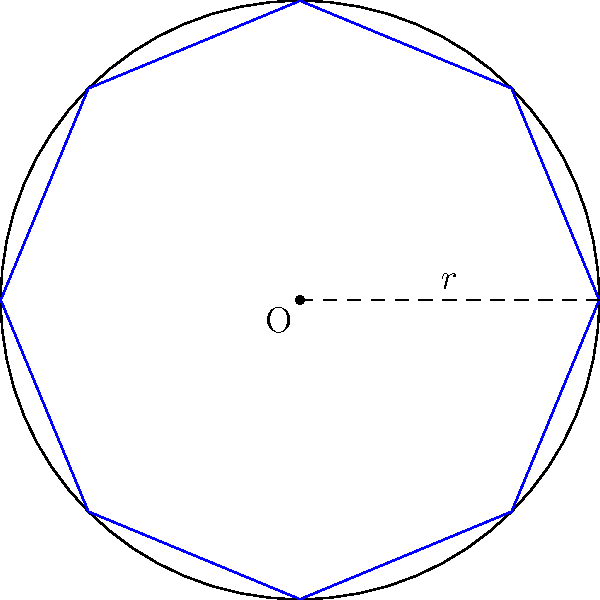A circle with radius $r$ has a regular octagon inscribed within it, as shown in the figure. If the radius of the circle is 10 cm, what is the perimeter of the inscribed octagon? Express your answer in terms of $\pi$ cm, rounded to two decimal places. Let's approach this step-by-step:

1) In a regular octagon, the central angle between any two adjacent vertices is $\frac{360°}{8} = 45°$.

2) The octagon can be divided into 8 congruent right triangles. Let's focus on one of these triangles.

3) In this right triangle:
   - The hypotenuse is the radius $r = 10$ cm.
   - The angle at the center is half of $45°$, which is $22.5°$.

4) The side of the octagon forms the base of this right triangle. Let's call its length $s$.

5) We can find $s$ using the cosine function:

   $\cos 22.5° = \frac{\frac{s}{2}}{r}$

6) Solving for $s$:

   $s = 2r \cos 22.5° = 2 \cdot 10 \cdot \cos 22.5° = 20 \cos 22.5°$

7) The perimeter of the octagon is 8 times this side length:

   $\text{Perimeter} = 8s = 8 \cdot 20 \cos 22.5° = 160 \cos 22.5°$

8) $\cos 22.5° = \frac{\sqrt{2+\sqrt{2}}}{2}$

9) Substituting this value:

   $\text{Perimeter} = 160 \cdot \frac{\sqrt{2+\sqrt{2}}}{2} = 80\sqrt{2+\sqrt{2}}$

10) To express in terms of $\pi$:
    
    $80\sqrt{2+\sqrt{2}} \approx 19.0291328\pi$

11) Rounding to two decimal places:

    $\text{Perimeter} \approx 19.03\pi$ cm
Answer: $19.03\pi$ cm 